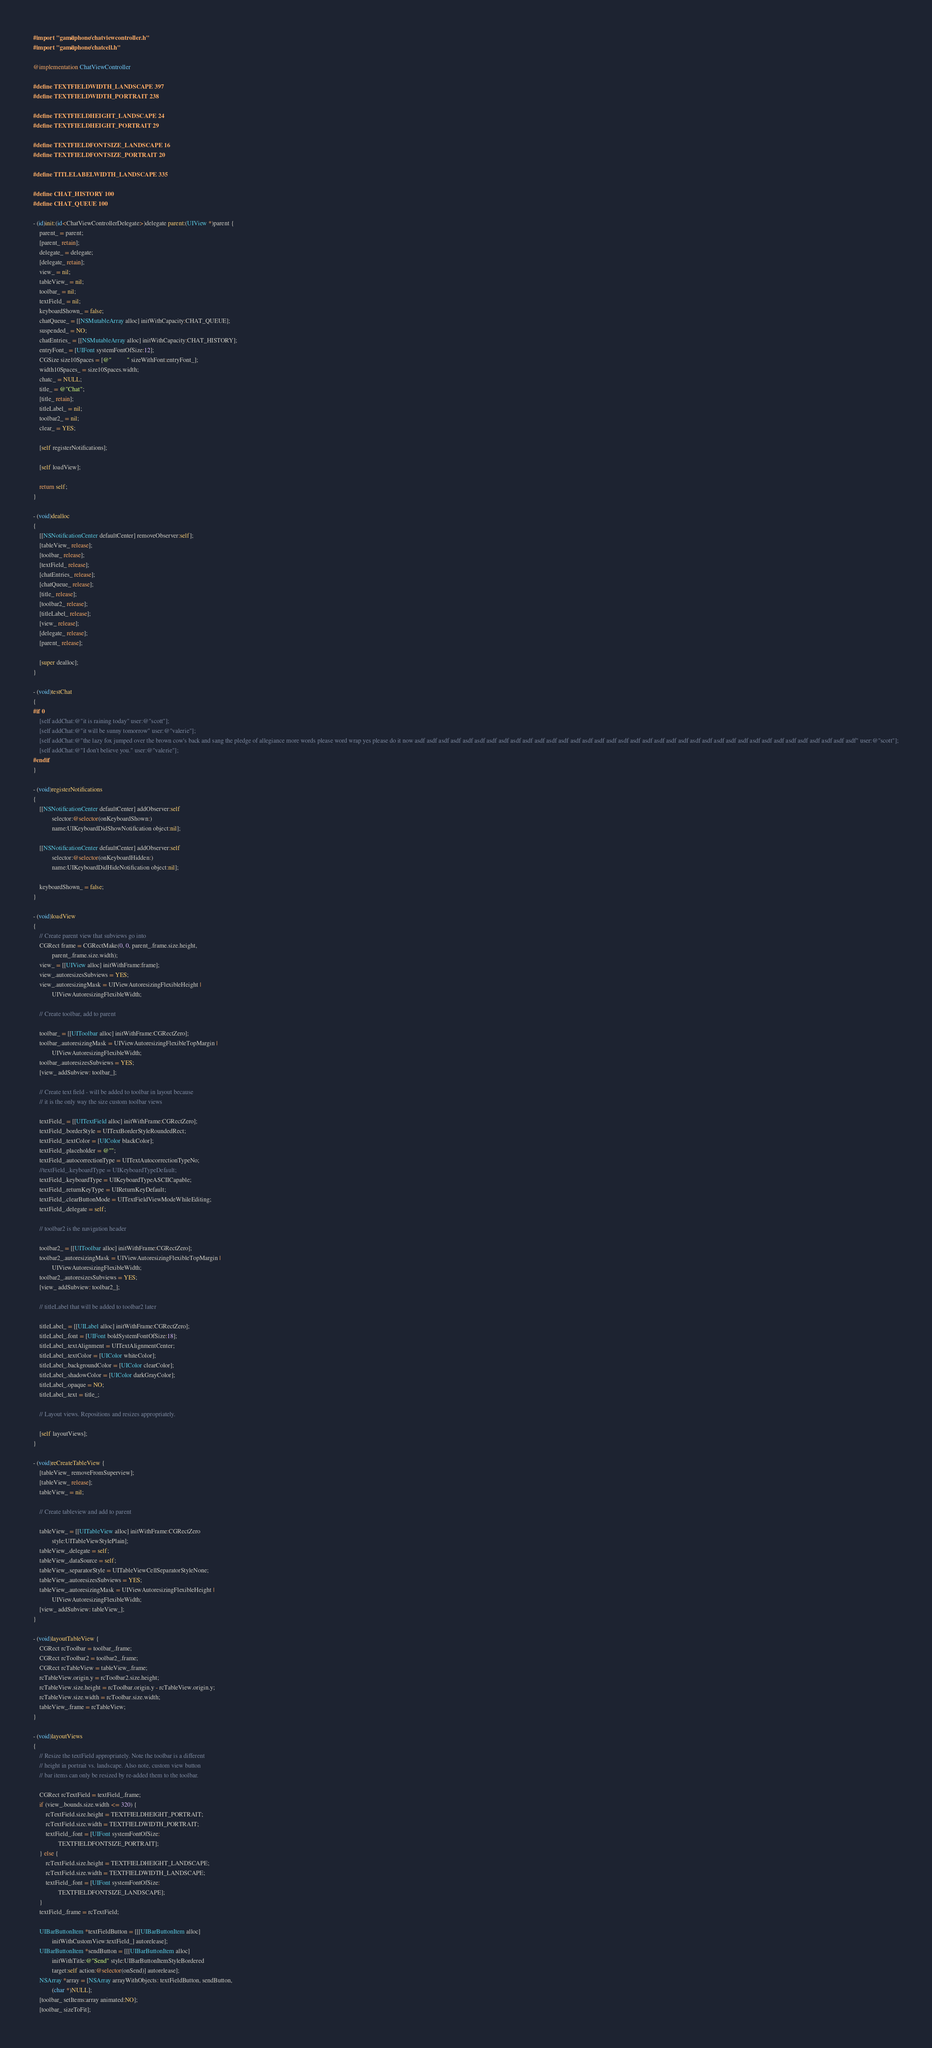<code> <loc_0><loc_0><loc_500><loc_500><_ObjectiveC_>#import "game/iphone/chatviewcontroller.h"
#import "game/iphone/chatcell.h"

@implementation ChatViewController

#define TEXTFIELDWIDTH_LANDSCAPE 397
#define TEXTFIELDWIDTH_PORTRAIT 238

#define TEXTFIELDHEIGHT_LANDSCAPE 24
#define TEXTFIELDHEIGHT_PORTRAIT 29

#define TEXTFIELDFONTSIZE_LANDSCAPE 16
#define TEXTFIELDFONTSIZE_PORTRAIT 20

#define TITLELABELWIDTH_LANDSCAPE 335

#define CHAT_HISTORY 100
#define CHAT_QUEUE 100

- (id)init:(id<ChatViewControllerDelegate>)delegate parent:(UIView *)parent {
    parent_ = parent;
    [parent_ retain];
    delegate_ = delegate;
    [delegate_ retain];
    view_ = nil;
    tableView_ = nil;
    toolbar_ = nil;
    textField_ = nil;
    keyboardShown_ = false;
    chatQueue_ = [[NSMutableArray alloc] initWithCapacity:CHAT_QUEUE];
    suspended_ = NO;
    chatEntries_ = [[NSMutableArray alloc] initWithCapacity:CHAT_HISTORY];
    entryFont_ = [UIFont systemFontOfSize:12];
    CGSize size10Spaces = [@"          " sizeWithFont:entryFont_];
    width10Spaces_ = size10Spaces.width;
    chatc_ = NULL;
    title_ = @"Chat";
    [title_ retain];
    titleLabel_ = nil;
    toolbar2_ = nil;
    clear_ = YES;

    [self registerNotifications];

    [self loadView];

    return self;
}

- (void)dealloc
{
    [[NSNotificationCenter defaultCenter] removeObserver:self];
    [tableView_ release];
    [toolbar_ release];
    [textField_ release];
    [chatEntries_ release];
    [chatQueue_ release];
    [title_ release];
    [toolbar2_ release];
    [titleLabel_ release];
    [view_ release];
    [delegate_ release];
    [parent_ release];

    [super dealloc];
}

- (void)testChat
{
#if 0
    [self addChat:@"it is raining today" user:@"scott"];
    [self addChat:@"it will be sunny tomorrow" user:@"valerie"];
    [self addChat:@"the lazy fox jumped over the brown cow's back and sang the pledge of allegiance more words please word wrap yes please do it now asdf asdf asdf asdf asdf asdf asdf asdf asdf asdf asdf asdf asdf asdf asdf asdf asdf asdf asdf asdf asdf asdf asdf asdf asdf asdf asdf asdf asdf asdf asdf asdf asdf asdf asdf asdf asdf" user:@"scott"];
    [self addChat:@"I don't believe you." user:@"valerie"];
#endif
}

- (void)registerNotifications
{
    [[NSNotificationCenter defaultCenter] addObserver:self
            selector:@selector(onKeyboardShown:)
            name:UIKeyboardDidShowNotification object:nil];
 
    [[NSNotificationCenter defaultCenter] addObserver:self
            selector:@selector(onKeyboardHidden:)
            name:UIKeyboardDidHideNotification object:nil];

    keyboardShown_ = false;
}

- (void)loadView
{
    // Create parent view that subviews go into
    CGRect frame = CGRectMake(0, 0, parent_.frame.size.height,
            parent_.frame.size.width);
    view_ = [[UIView alloc] initWithFrame:frame];
    view_.autoresizesSubviews = YES;
    view_.autoresizingMask = UIViewAutoresizingFlexibleHeight |
            UIViewAutoresizingFlexibleWidth;

    // Create toolbar, add to parent

    toolbar_ = [[UIToolbar alloc] initWithFrame:CGRectZero];
    toolbar_.autoresizingMask = UIViewAutoresizingFlexibleTopMargin |
            UIViewAutoresizingFlexibleWidth;
    toolbar_.autoresizesSubviews = YES;
    [view_ addSubview: toolbar_];

    // Create text field - will be added to toolbar in layout because
    // it is the only way the size custom toolbar views

    textField_ = [[UITextField alloc] initWithFrame:CGRectZero];
    textField_.borderStyle = UITextBorderStyleRoundedRect;
    textField_.textColor = [UIColor blackColor];
    textField_.placeholder = @"";
    textField_.autocorrectionType = UITextAutocorrectionTypeNo;
    //textField_.keyboardType = UIKeyboardTypeDefault;
    textField_.keyboardType = UIKeyboardTypeASCIICapable;
    textField_.returnKeyType = UIReturnKeyDefault;
    textField_.clearButtonMode = UITextFieldViewModeWhileEditing;
    textField_.delegate = self;

    // toolbar2 is the navigation header

    toolbar2_ = [[UIToolbar alloc] initWithFrame:CGRectZero];
    toolbar2_.autoresizingMask = UIViewAutoresizingFlexibleTopMargin |
            UIViewAutoresizingFlexibleWidth;
    toolbar2_.autoresizesSubviews = YES;
    [view_ addSubview: toolbar2_];

    // titleLabel that will be added to toolbar2 later

    titleLabel_ = [[UILabel alloc] initWithFrame:CGRectZero];
    titleLabel_.font = [UIFont boldSystemFontOfSize:18];
    titleLabel_.textAlignment = UITextAlignmentCenter;
    titleLabel_.textColor = [UIColor whiteColor];
    titleLabel_.backgroundColor = [UIColor clearColor];
    titleLabel_.shadowColor = [UIColor darkGrayColor];
    titleLabel_.opaque = NO;
    titleLabel_.text = title_;

    // Layout views. Repositions and resizes appropriately.

    [self layoutViews];
}

- (void)reCreateTableView {
    [tableView_ removeFromSuperview];
    [tableView_ release];
    tableView_ = nil;

    // Create tableview and add to parent

    tableView_ = [[UITableView alloc] initWithFrame:CGRectZero
            style:UITableViewStylePlain];
    tableView_.delegate = self;
    tableView_.dataSource = self;
    tableView_.separatorStyle = UITableViewCellSeparatorStyleNone;
    tableView_.autoresizesSubviews = YES;
    tableView_.autoresizingMask = UIViewAutoresizingFlexibleHeight |
            UIViewAutoresizingFlexibleWidth;
    [view_ addSubview: tableView_];
}

- (void)layoutTableView {
    CGRect rcToolbar = toolbar_.frame;
    CGRect rcToolbar2 = toolbar2_.frame;
    CGRect rcTableView = tableView_.frame;
    rcTableView.origin.y = rcToolbar2.size.height;
    rcTableView.size.height = rcToolbar.origin.y - rcTableView.origin.y;
    rcTableView.size.width = rcToolbar.size.width;
    tableView_.frame = rcTableView;
}

- (void)layoutViews
{
    // Resize the textField appropriately. Note the toolbar is a different
    // height in portrait vs. landscape. Also note, custom view button
    // bar items can only be resized by re-added them to the toolbar.

    CGRect rcTextField = textField_.frame;
    if (view_.bounds.size.width <= 320) {
        rcTextField.size.height = TEXTFIELDHEIGHT_PORTRAIT;
        rcTextField.size.width = TEXTFIELDWIDTH_PORTRAIT;
        textField_.font = [UIFont systemFontOfSize:
                TEXTFIELDFONTSIZE_PORTRAIT];
    } else {
        rcTextField.size.height = TEXTFIELDHEIGHT_LANDSCAPE;
        rcTextField.size.width = TEXTFIELDWIDTH_LANDSCAPE;
        textField_.font = [UIFont systemFontOfSize:
                TEXTFIELDFONTSIZE_LANDSCAPE];
    }
    textField_.frame = rcTextField;

    UIBarButtonItem *textFieldButton = [[[UIBarButtonItem alloc]
            initWithCustomView:textField_] autorelease];
    UIBarButtonItem *sendButton = [[[UIBarButtonItem alloc]
            initWithTitle:@"Send" style:UIBarButtonItemStyleBordered
            target:self action:@selector(onSend)] autorelease];
    NSArray *array = [NSArray arrayWithObjects: textFieldButton, sendButton,
            (char *)NULL];
    [toolbar_ setItems:array animated:NO];
    [toolbar_ sizeToFit];
</code> 